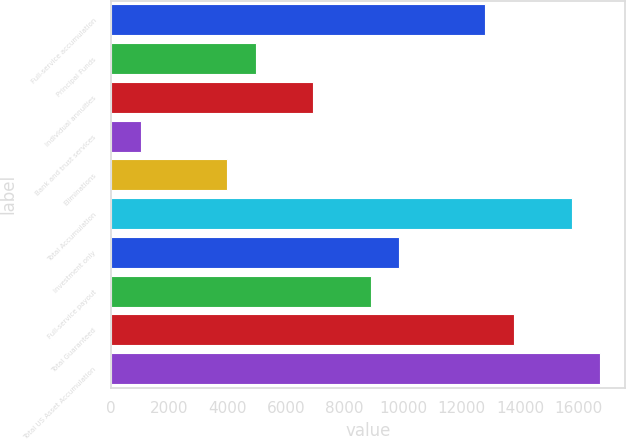Convert chart. <chart><loc_0><loc_0><loc_500><loc_500><bar_chart><fcel>Full-service accumulation<fcel>Principal Funds<fcel>Individual annuities<fcel>Bank and trust services<fcel>Eliminations<fcel>Total Accumulation<fcel>Investment only<fcel>Full-service payout<fcel>Total Guaranteed<fcel>Total US Asset Accumulation<nl><fcel>12821.8<fcel>4958.65<fcel>6924.43<fcel>1027.09<fcel>3975.76<fcel>15770.4<fcel>9873.1<fcel>8890.21<fcel>13804.7<fcel>16753.3<nl></chart> 